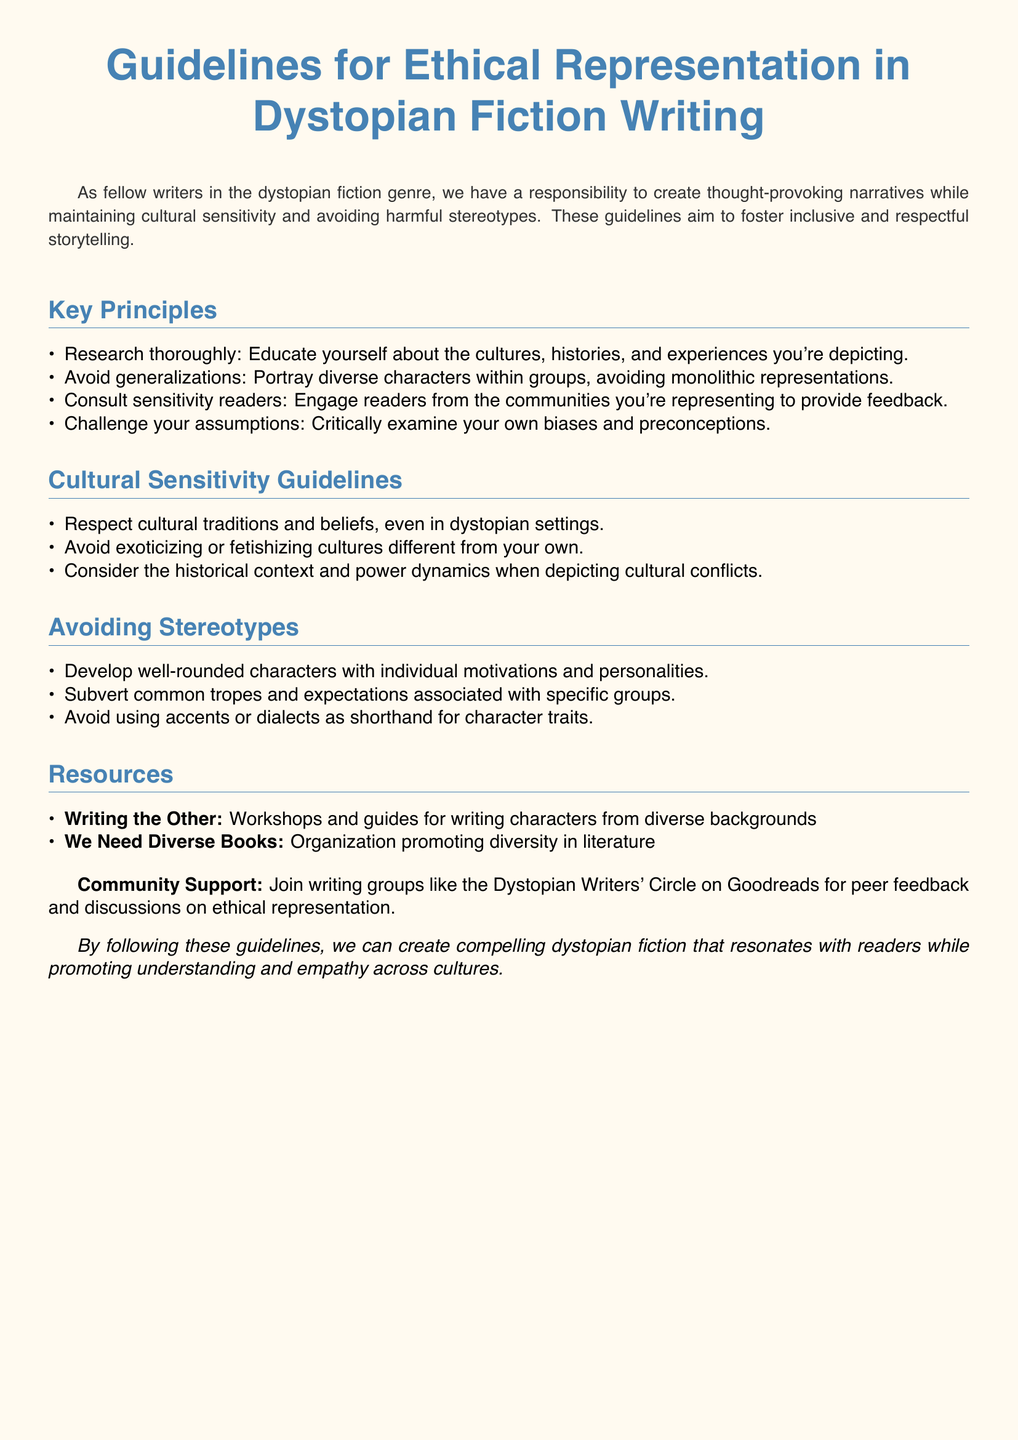What is the title of the document? The title is displayed prominently at the top of the document as the main heading.
Answer: Guidelines for Ethical Representation in Dystopian Fiction Writing What is the first key principle listed? The first key principle is found in the list under the section titled "Key Principles."
Answer: Research thoroughly Name one resource mentioned in the document. Resources are provided in a specific section, listing organizations and workshops related to writing.
Answer: Writing the Other How many guidelines are in the Cultural Sensitivity section? The number of guidelines in this section can be counted from the list provided.
Answer: Three What type of readers does the document suggest consulting? The document recommends engaging individuals from relevant communities to gather feedback.
Answer: Sensitivity readers What should writers challenge according to the guidelines? The guidelines encourage writers to reflect on their own mental processes and biases.
Answer: Assumptions What is the purpose of these guidelines? The document states its purpose to promote better narratives in dystopian fiction while showing respect and sensitivity.
Answer: Foster inclusive and respectful storytelling How does the document suggest writers avoid harmful stereotypes? The guidelines provide specific actions writers can take to prevent stereotypes from influencing their characters.
Answer: Develop well-rounded characters 